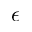<formula> <loc_0><loc_0><loc_500><loc_500>\epsilon</formula> 